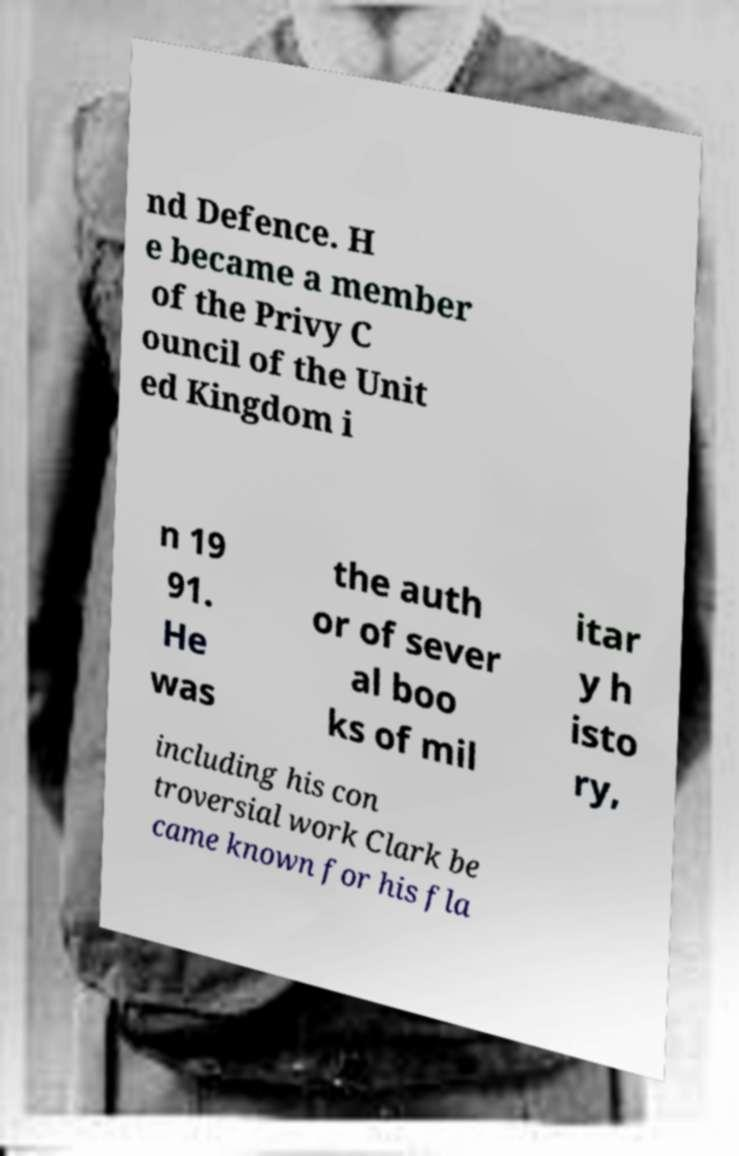There's text embedded in this image that I need extracted. Can you transcribe it verbatim? nd Defence. H e became a member of the Privy C ouncil of the Unit ed Kingdom i n 19 91. He was the auth or of sever al boo ks of mil itar y h isto ry, including his con troversial work Clark be came known for his fla 